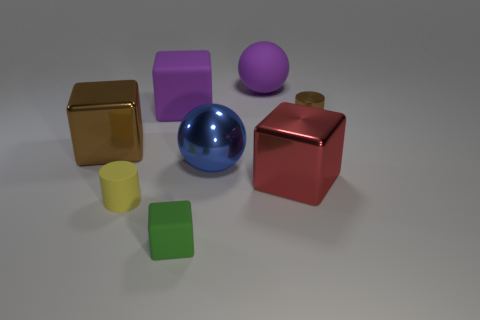There is a purple cube that is the same material as the small yellow cylinder; what size is it?
Offer a very short reply. Large. How many purple things have the same shape as the green rubber object?
Keep it short and to the point. 1. Is the number of small brown shiny objects that are to the right of the small rubber cylinder greater than the number of purple objects that are on the right side of the brown cylinder?
Keep it short and to the point. Yes. Is the color of the large rubber block the same as the large cube to the right of the large blue metallic sphere?
Offer a very short reply. No. There is a brown cube that is the same size as the blue ball; what is it made of?
Provide a short and direct response. Metal. What number of things are either large red matte balls or large shiny things that are to the left of the red block?
Keep it short and to the point. 2. There is a green rubber block; is its size the same as the cylinder that is to the right of the large blue object?
Provide a short and direct response. Yes. How many blocks are big red matte objects or yellow matte things?
Make the answer very short. 0. How many small things are both on the left side of the small metal cylinder and on the right side of the yellow matte cylinder?
Your response must be concise. 1. What number of other objects are there of the same color as the large matte sphere?
Provide a succinct answer. 1. 